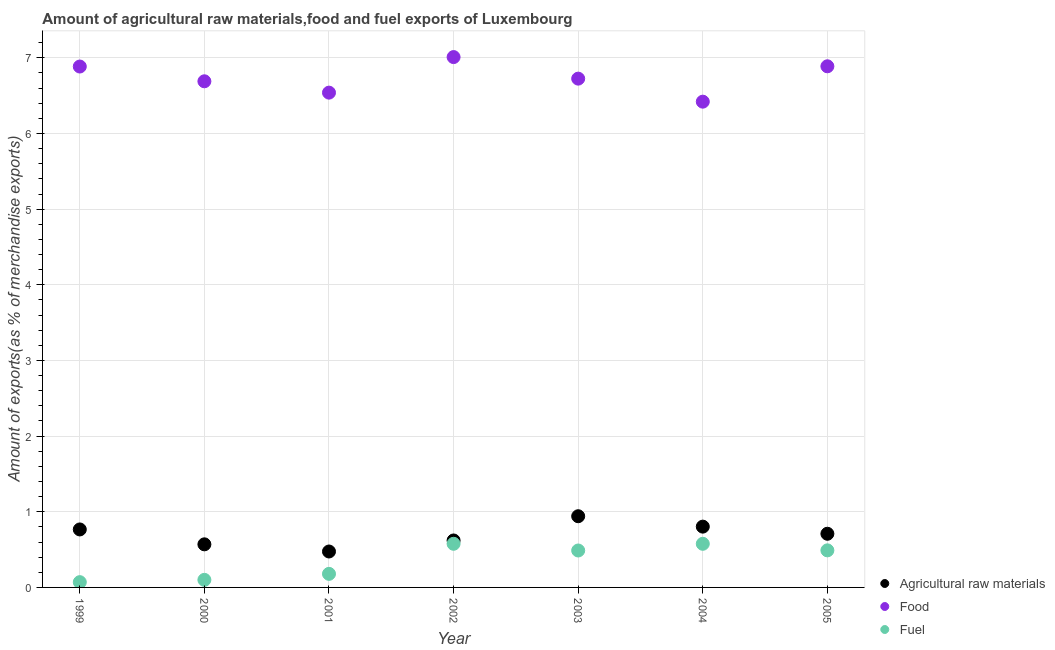What is the percentage of raw materials exports in 1999?
Keep it short and to the point. 0.77. Across all years, what is the maximum percentage of food exports?
Give a very brief answer. 7.01. Across all years, what is the minimum percentage of raw materials exports?
Your response must be concise. 0.47. In which year was the percentage of raw materials exports maximum?
Ensure brevity in your answer.  2003. In which year was the percentage of raw materials exports minimum?
Ensure brevity in your answer.  2001. What is the total percentage of food exports in the graph?
Make the answer very short. 47.16. What is the difference between the percentage of fuel exports in 1999 and that in 2001?
Offer a terse response. -0.11. What is the difference between the percentage of raw materials exports in 2002 and the percentage of food exports in 2004?
Your answer should be very brief. -5.8. What is the average percentage of fuel exports per year?
Keep it short and to the point. 0.35. In the year 2000, what is the difference between the percentage of fuel exports and percentage of raw materials exports?
Give a very brief answer. -0.47. What is the ratio of the percentage of food exports in 2004 to that in 2005?
Your answer should be compact. 0.93. Is the percentage of fuel exports in 2002 less than that in 2005?
Offer a terse response. No. Is the difference between the percentage of food exports in 2001 and 2002 greater than the difference between the percentage of raw materials exports in 2001 and 2002?
Make the answer very short. No. What is the difference between the highest and the second highest percentage of raw materials exports?
Provide a short and direct response. 0.14. What is the difference between the highest and the lowest percentage of fuel exports?
Make the answer very short. 0.51. Is the sum of the percentage of raw materials exports in 2000 and 2002 greater than the maximum percentage of food exports across all years?
Keep it short and to the point. No. Is it the case that in every year, the sum of the percentage of raw materials exports and percentage of food exports is greater than the percentage of fuel exports?
Your answer should be very brief. Yes. How many dotlines are there?
Give a very brief answer. 3. Where does the legend appear in the graph?
Offer a very short reply. Bottom right. What is the title of the graph?
Make the answer very short. Amount of agricultural raw materials,food and fuel exports of Luxembourg. Does "Capital account" appear as one of the legend labels in the graph?
Provide a short and direct response. No. What is the label or title of the Y-axis?
Offer a very short reply. Amount of exports(as % of merchandise exports). What is the Amount of exports(as % of merchandise exports) in Agricultural raw materials in 1999?
Offer a very short reply. 0.77. What is the Amount of exports(as % of merchandise exports) of Food in 1999?
Make the answer very short. 6.88. What is the Amount of exports(as % of merchandise exports) of Fuel in 1999?
Your answer should be very brief. 0.07. What is the Amount of exports(as % of merchandise exports) of Agricultural raw materials in 2000?
Your answer should be compact. 0.57. What is the Amount of exports(as % of merchandise exports) of Food in 2000?
Your answer should be very brief. 6.69. What is the Amount of exports(as % of merchandise exports) in Fuel in 2000?
Your answer should be very brief. 0.1. What is the Amount of exports(as % of merchandise exports) in Agricultural raw materials in 2001?
Keep it short and to the point. 0.47. What is the Amount of exports(as % of merchandise exports) of Food in 2001?
Keep it short and to the point. 6.54. What is the Amount of exports(as % of merchandise exports) in Fuel in 2001?
Offer a terse response. 0.18. What is the Amount of exports(as % of merchandise exports) of Agricultural raw materials in 2002?
Make the answer very short. 0.62. What is the Amount of exports(as % of merchandise exports) in Food in 2002?
Offer a terse response. 7.01. What is the Amount of exports(as % of merchandise exports) of Fuel in 2002?
Make the answer very short. 0.58. What is the Amount of exports(as % of merchandise exports) of Agricultural raw materials in 2003?
Offer a very short reply. 0.94. What is the Amount of exports(as % of merchandise exports) in Food in 2003?
Provide a short and direct response. 6.72. What is the Amount of exports(as % of merchandise exports) of Fuel in 2003?
Provide a short and direct response. 0.49. What is the Amount of exports(as % of merchandise exports) of Agricultural raw materials in 2004?
Your response must be concise. 0.8. What is the Amount of exports(as % of merchandise exports) of Food in 2004?
Provide a short and direct response. 6.42. What is the Amount of exports(as % of merchandise exports) in Fuel in 2004?
Make the answer very short. 0.58. What is the Amount of exports(as % of merchandise exports) in Agricultural raw materials in 2005?
Provide a succinct answer. 0.71. What is the Amount of exports(as % of merchandise exports) of Food in 2005?
Give a very brief answer. 6.89. What is the Amount of exports(as % of merchandise exports) in Fuel in 2005?
Offer a very short reply. 0.49. Across all years, what is the maximum Amount of exports(as % of merchandise exports) in Agricultural raw materials?
Give a very brief answer. 0.94. Across all years, what is the maximum Amount of exports(as % of merchandise exports) in Food?
Provide a succinct answer. 7.01. Across all years, what is the maximum Amount of exports(as % of merchandise exports) of Fuel?
Offer a very short reply. 0.58. Across all years, what is the minimum Amount of exports(as % of merchandise exports) in Agricultural raw materials?
Your answer should be very brief. 0.47. Across all years, what is the minimum Amount of exports(as % of merchandise exports) in Food?
Provide a short and direct response. 6.42. Across all years, what is the minimum Amount of exports(as % of merchandise exports) in Fuel?
Offer a terse response. 0.07. What is the total Amount of exports(as % of merchandise exports) of Agricultural raw materials in the graph?
Your answer should be very brief. 4.89. What is the total Amount of exports(as % of merchandise exports) in Food in the graph?
Offer a terse response. 47.16. What is the total Amount of exports(as % of merchandise exports) of Fuel in the graph?
Offer a very short reply. 2.48. What is the difference between the Amount of exports(as % of merchandise exports) of Agricultural raw materials in 1999 and that in 2000?
Provide a short and direct response. 0.2. What is the difference between the Amount of exports(as % of merchandise exports) in Food in 1999 and that in 2000?
Provide a short and direct response. 0.2. What is the difference between the Amount of exports(as % of merchandise exports) in Fuel in 1999 and that in 2000?
Provide a succinct answer. -0.03. What is the difference between the Amount of exports(as % of merchandise exports) in Agricultural raw materials in 1999 and that in 2001?
Offer a very short reply. 0.29. What is the difference between the Amount of exports(as % of merchandise exports) of Food in 1999 and that in 2001?
Your response must be concise. 0.35. What is the difference between the Amount of exports(as % of merchandise exports) in Fuel in 1999 and that in 2001?
Offer a terse response. -0.11. What is the difference between the Amount of exports(as % of merchandise exports) in Agricultural raw materials in 1999 and that in 2002?
Ensure brevity in your answer.  0.15. What is the difference between the Amount of exports(as % of merchandise exports) of Food in 1999 and that in 2002?
Offer a terse response. -0.12. What is the difference between the Amount of exports(as % of merchandise exports) of Fuel in 1999 and that in 2002?
Provide a succinct answer. -0.51. What is the difference between the Amount of exports(as % of merchandise exports) in Agricultural raw materials in 1999 and that in 2003?
Your answer should be very brief. -0.17. What is the difference between the Amount of exports(as % of merchandise exports) in Food in 1999 and that in 2003?
Provide a succinct answer. 0.16. What is the difference between the Amount of exports(as % of merchandise exports) of Fuel in 1999 and that in 2003?
Your answer should be very brief. -0.42. What is the difference between the Amount of exports(as % of merchandise exports) of Agricultural raw materials in 1999 and that in 2004?
Ensure brevity in your answer.  -0.04. What is the difference between the Amount of exports(as % of merchandise exports) of Food in 1999 and that in 2004?
Offer a very short reply. 0.46. What is the difference between the Amount of exports(as % of merchandise exports) in Fuel in 1999 and that in 2004?
Give a very brief answer. -0.51. What is the difference between the Amount of exports(as % of merchandise exports) in Agricultural raw materials in 1999 and that in 2005?
Provide a succinct answer. 0.06. What is the difference between the Amount of exports(as % of merchandise exports) in Food in 1999 and that in 2005?
Make the answer very short. -0. What is the difference between the Amount of exports(as % of merchandise exports) of Fuel in 1999 and that in 2005?
Keep it short and to the point. -0.42. What is the difference between the Amount of exports(as % of merchandise exports) in Agricultural raw materials in 2000 and that in 2001?
Your answer should be compact. 0.09. What is the difference between the Amount of exports(as % of merchandise exports) of Fuel in 2000 and that in 2001?
Offer a terse response. -0.08. What is the difference between the Amount of exports(as % of merchandise exports) in Agricultural raw materials in 2000 and that in 2002?
Make the answer very short. -0.05. What is the difference between the Amount of exports(as % of merchandise exports) of Food in 2000 and that in 2002?
Keep it short and to the point. -0.32. What is the difference between the Amount of exports(as % of merchandise exports) in Fuel in 2000 and that in 2002?
Keep it short and to the point. -0.48. What is the difference between the Amount of exports(as % of merchandise exports) of Agricultural raw materials in 2000 and that in 2003?
Provide a succinct answer. -0.37. What is the difference between the Amount of exports(as % of merchandise exports) of Food in 2000 and that in 2003?
Your answer should be compact. -0.04. What is the difference between the Amount of exports(as % of merchandise exports) of Fuel in 2000 and that in 2003?
Make the answer very short. -0.39. What is the difference between the Amount of exports(as % of merchandise exports) in Agricultural raw materials in 2000 and that in 2004?
Give a very brief answer. -0.23. What is the difference between the Amount of exports(as % of merchandise exports) of Food in 2000 and that in 2004?
Your answer should be compact. 0.27. What is the difference between the Amount of exports(as % of merchandise exports) of Fuel in 2000 and that in 2004?
Provide a succinct answer. -0.48. What is the difference between the Amount of exports(as % of merchandise exports) of Agricultural raw materials in 2000 and that in 2005?
Ensure brevity in your answer.  -0.14. What is the difference between the Amount of exports(as % of merchandise exports) in Food in 2000 and that in 2005?
Keep it short and to the point. -0.2. What is the difference between the Amount of exports(as % of merchandise exports) of Fuel in 2000 and that in 2005?
Provide a succinct answer. -0.39. What is the difference between the Amount of exports(as % of merchandise exports) in Agricultural raw materials in 2001 and that in 2002?
Your response must be concise. -0.15. What is the difference between the Amount of exports(as % of merchandise exports) of Food in 2001 and that in 2002?
Offer a terse response. -0.47. What is the difference between the Amount of exports(as % of merchandise exports) of Fuel in 2001 and that in 2002?
Your answer should be compact. -0.4. What is the difference between the Amount of exports(as % of merchandise exports) of Agricultural raw materials in 2001 and that in 2003?
Offer a terse response. -0.47. What is the difference between the Amount of exports(as % of merchandise exports) in Food in 2001 and that in 2003?
Make the answer very short. -0.19. What is the difference between the Amount of exports(as % of merchandise exports) in Fuel in 2001 and that in 2003?
Ensure brevity in your answer.  -0.31. What is the difference between the Amount of exports(as % of merchandise exports) in Agricultural raw materials in 2001 and that in 2004?
Offer a terse response. -0.33. What is the difference between the Amount of exports(as % of merchandise exports) in Food in 2001 and that in 2004?
Offer a very short reply. 0.12. What is the difference between the Amount of exports(as % of merchandise exports) of Fuel in 2001 and that in 2004?
Keep it short and to the point. -0.4. What is the difference between the Amount of exports(as % of merchandise exports) in Agricultural raw materials in 2001 and that in 2005?
Ensure brevity in your answer.  -0.23. What is the difference between the Amount of exports(as % of merchandise exports) of Food in 2001 and that in 2005?
Make the answer very short. -0.35. What is the difference between the Amount of exports(as % of merchandise exports) in Fuel in 2001 and that in 2005?
Offer a terse response. -0.31. What is the difference between the Amount of exports(as % of merchandise exports) in Agricultural raw materials in 2002 and that in 2003?
Make the answer very short. -0.32. What is the difference between the Amount of exports(as % of merchandise exports) in Food in 2002 and that in 2003?
Provide a succinct answer. 0.28. What is the difference between the Amount of exports(as % of merchandise exports) of Fuel in 2002 and that in 2003?
Offer a very short reply. 0.09. What is the difference between the Amount of exports(as % of merchandise exports) in Agricultural raw materials in 2002 and that in 2004?
Make the answer very short. -0.18. What is the difference between the Amount of exports(as % of merchandise exports) of Food in 2002 and that in 2004?
Offer a terse response. 0.59. What is the difference between the Amount of exports(as % of merchandise exports) of Fuel in 2002 and that in 2004?
Ensure brevity in your answer.  0. What is the difference between the Amount of exports(as % of merchandise exports) in Agricultural raw materials in 2002 and that in 2005?
Offer a terse response. -0.09. What is the difference between the Amount of exports(as % of merchandise exports) in Food in 2002 and that in 2005?
Your answer should be very brief. 0.12. What is the difference between the Amount of exports(as % of merchandise exports) in Fuel in 2002 and that in 2005?
Provide a short and direct response. 0.09. What is the difference between the Amount of exports(as % of merchandise exports) of Agricultural raw materials in 2003 and that in 2004?
Your response must be concise. 0.14. What is the difference between the Amount of exports(as % of merchandise exports) of Food in 2003 and that in 2004?
Your answer should be compact. 0.3. What is the difference between the Amount of exports(as % of merchandise exports) of Fuel in 2003 and that in 2004?
Provide a succinct answer. -0.09. What is the difference between the Amount of exports(as % of merchandise exports) in Agricultural raw materials in 2003 and that in 2005?
Make the answer very short. 0.23. What is the difference between the Amount of exports(as % of merchandise exports) in Food in 2003 and that in 2005?
Your response must be concise. -0.16. What is the difference between the Amount of exports(as % of merchandise exports) of Fuel in 2003 and that in 2005?
Give a very brief answer. -0. What is the difference between the Amount of exports(as % of merchandise exports) of Agricultural raw materials in 2004 and that in 2005?
Give a very brief answer. 0.09. What is the difference between the Amount of exports(as % of merchandise exports) in Food in 2004 and that in 2005?
Provide a succinct answer. -0.47. What is the difference between the Amount of exports(as % of merchandise exports) of Fuel in 2004 and that in 2005?
Provide a short and direct response. 0.09. What is the difference between the Amount of exports(as % of merchandise exports) in Agricultural raw materials in 1999 and the Amount of exports(as % of merchandise exports) in Food in 2000?
Ensure brevity in your answer.  -5.92. What is the difference between the Amount of exports(as % of merchandise exports) in Agricultural raw materials in 1999 and the Amount of exports(as % of merchandise exports) in Fuel in 2000?
Offer a very short reply. 0.67. What is the difference between the Amount of exports(as % of merchandise exports) of Food in 1999 and the Amount of exports(as % of merchandise exports) of Fuel in 2000?
Your answer should be compact. 6.79. What is the difference between the Amount of exports(as % of merchandise exports) in Agricultural raw materials in 1999 and the Amount of exports(as % of merchandise exports) in Food in 2001?
Your response must be concise. -5.77. What is the difference between the Amount of exports(as % of merchandise exports) in Agricultural raw materials in 1999 and the Amount of exports(as % of merchandise exports) in Fuel in 2001?
Give a very brief answer. 0.59. What is the difference between the Amount of exports(as % of merchandise exports) of Food in 1999 and the Amount of exports(as % of merchandise exports) of Fuel in 2001?
Provide a succinct answer. 6.71. What is the difference between the Amount of exports(as % of merchandise exports) in Agricultural raw materials in 1999 and the Amount of exports(as % of merchandise exports) in Food in 2002?
Offer a terse response. -6.24. What is the difference between the Amount of exports(as % of merchandise exports) in Agricultural raw materials in 1999 and the Amount of exports(as % of merchandise exports) in Fuel in 2002?
Keep it short and to the point. 0.19. What is the difference between the Amount of exports(as % of merchandise exports) of Food in 1999 and the Amount of exports(as % of merchandise exports) of Fuel in 2002?
Provide a succinct answer. 6.31. What is the difference between the Amount of exports(as % of merchandise exports) in Agricultural raw materials in 1999 and the Amount of exports(as % of merchandise exports) in Food in 2003?
Offer a terse response. -5.96. What is the difference between the Amount of exports(as % of merchandise exports) of Agricultural raw materials in 1999 and the Amount of exports(as % of merchandise exports) of Fuel in 2003?
Keep it short and to the point. 0.28. What is the difference between the Amount of exports(as % of merchandise exports) of Food in 1999 and the Amount of exports(as % of merchandise exports) of Fuel in 2003?
Make the answer very short. 6.4. What is the difference between the Amount of exports(as % of merchandise exports) of Agricultural raw materials in 1999 and the Amount of exports(as % of merchandise exports) of Food in 2004?
Offer a terse response. -5.65. What is the difference between the Amount of exports(as % of merchandise exports) in Agricultural raw materials in 1999 and the Amount of exports(as % of merchandise exports) in Fuel in 2004?
Your response must be concise. 0.19. What is the difference between the Amount of exports(as % of merchandise exports) in Food in 1999 and the Amount of exports(as % of merchandise exports) in Fuel in 2004?
Your response must be concise. 6.31. What is the difference between the Amount of exports(as % of merchandise exports) in Agricultural raw materials in 1999 and the Amount of exports(as % of merchandise exports) in Food in 2005?
Offer a terse response. -6.12. What is the difference between the Amount of exports(as % of merchandise exports) in Agricultural raw materials in 1999 and the Amount of exports(as % of merchandise exports) in Fuel in 2005?
Offer a terse response. 0.28. What is the difference between the Amount of exports(as % of merchandise exports) in Food in 1999 and the Amount of exports(as % of merchandise exports) in Fuel in 2005?
Offer a very short reply. 6.39. What is the difference between the Amount of exports(as % of merchandise exports) of Agricultural raw materials in 2000 and the Amount of exports(as % of merchandise exports) of Food in 2001?
Give a very brief answer. -5.97. What is the difference between the Amount of exports(as % of merchandise exports) of Agricultural raw materials in 2000 and the Amount of exports(as % of merchandise exports) of Fuel in 2001?
Provide a succinct answer. 0.39. What is the difference between the Amount of exports(as % of merchandise exports) of Food in 2000 and the Amount of exports(as % of merchandise exports) of Fuel in 2001?
Offer a terse response. 6.51. What is the difference between the Amount of exports(as % of merchandise exports) of Agricultural raw materials in 2000 and the Amount of exports(as % of merchandise exports) of Food in 2002?
Keep it short and to the point. -6.44. What is the difference between the Amount of exports(as % of merchandise exports) of Agricultural raw materials in 2000 and the Amount of exports(as % of merchandise exports) of Fuel in 2002?
Provide a short and direct response. -0.01. What is the difference between the Amount of exports(as % of merchandise exports) in Food in 2000 and the Amount of exports(as % of merchandise exports) in Fuel in 2002?
Offer a very short reply. 6.11. What is the difference between the Amount of exports(as % of merchandise exports) of Agricultural raw materials in 2000 and the Amount of exports(as % of merchandise exports) of Food in 2003?
Make the answer very short. -6.16. What is the difference between the Amount of exports(as % of merchandise exports) in Agricultural raw materials in 2000 and the Amount of exports(as % of merchandise exports) in Fuel in 2003?
Make the answer very short. 0.08. What is the difference between the Amount of exports(as % of merchandise exports) in Food in 2000 and the Amount of exports(as % of merchandise exports) in Fuel in 2003?
Provide a succinct answer. 6.2. What is the difference between the Amount of exports(as % of merchandise exports) in Agricultural raw materials in 2000 and the Amount of exports(as % of merchandise exports) in Food in 2004?
Your answer should be very brief. -5.85. What is the difference between the Amount of exports(as % of merchandise exports) of Agricultural raw materials in 2000 and the Amount of exports(as % of merchandise exports) of Fuel in 2004?
Make the answer very short. -0.01. What is the difference between the Amount of exports(as % of merchandise exports) in Food in 2000 and the Amount of exports(as % of merchandise exports) in Fuel in 2004?
Offer a very short reply. 6.11. What is the difference between the Amount of exports(as % of merchandise exports) in Agricultural raw materials in 2000 and the Amount of exports(as % of merchandise exports) in Food in 2005?
Your answer should be compact. -6.32. What is the difference between the Amount of exports(as % of merchandise exports) in Agricultural raw materials in 2000 and the Amount of exports(as % of merchandise exports) in Fuel in 2005?
Give a very brief answer. 0.08. What is the difference between the Amount of exports(as % of merchandise exports) in Food in 2000 and the Amount of exports(as % of merchandise exports) in Fuel in 2005?
Make the answer very short. 6.2. What is the difference between the Amount of exports(as % of merchandise exports) of Agricultural raw materials in 2001 and the Amount of exports(as % of merchandise exports) of Food in 2002?
Offer a terse response. -6.54. What is the difference between the Amount of exports(as % of merchandise exports) of Agricultural raw materials in 2001 and the Amount of exports(as % of merchandise exports) of Fuel in 2002?
Make the answer very short. -0.1. What is the difference between the Amount of exports(as % of merchandise exports) of Food in 2001 and the Amount of exports(as % of merchandise exports) of Fuel in 2002?
Provide a succinct answer. 5.96. What is the difference between the Amount of exports(as % of merchandise exports) in Agricultural raw materials in 2001 and the Amount of exports(as % of merchandise exports) in Food in 2003?
Ensure brevity in your answer.  -6.25. What is the difference between the Amount of exports(as % of merchandise exports) in Agricultural raw materials in 2001 and the Amount of exports(as % of merchandise exports) in Fuel in 2003?
Give a very brief answer. -0.01. What is the difference between the Amount of exports(as % of merchandise exports) of Food in 2001 and the Amount of exports(as % of merchandise exports) of Fuel in 2003?
Offer a very short reply. 6.05. What is the difference between the Amount of exports(as % of merchandise exports) of Agricultural raw materials in 2001 and the Amount of exports(as % of merchandise exports) of Food in 2004?
Give a very brief answer. -5.95. What is the difference between the Amount of exports(as % of merchandise exports) of Agricultural raw materials in 2001 and the Amount of exports(as % of merchandise exports) of Fuel in 2004?
Give a very brief answer. -0.1. What is the difference between the Amount of exports(as % of merchandise exports) in Food in 2001 and the Amount of exports(as % of merchandise exports) in Fuel in 2004?
Your response must be concise. 5.96. What is the difference between the Amount of exports(as % of merchandise exports) of Agricultural raw materials in 2001 and the Amount of exports(as % of merchandise exports) of Food in 2005?
Ensure brevity in your answer.  -6.41. What is the difference between the Amount of exports(as % of merchandise exports) in Agricultural raw materials in 2001 and the Amount of exports(as % of merchandise exports) in Fuel in 2005?
Offer a very short reply. -0.02. What is the difference between the Amount of exports(as % of merchandise exports) in Food in 2001 and the Amount of exports(as % of merchandise exports) in Fuel in 2005?
Provide a short and direct response. 6.05. What is the difference between the Amount of exports(as % of merchandise exports) in Agricultural raw materials in 2002 and the Amount of exports(as % of merchandise exports) in Food in 2003?
Your answer should be very brief. -6.1. What is the difference between the Amount of exports(as % of merchandise exports) in Agricultural raw materials in 2002 and the Amount of exports(as % of merchandise exports) in Fuel in 2003?
Offer a very short reply. 0.13. What is the difference between the Amount of exports(as % of merchandise exports) in Food in 2002 and the Amount of exports(as % of merchandise exports) in Fuel in 2003?
Your response must be concise. 6.52. What is the difference between the Amount of exports(as % of merchandise exports) of Agricultural raw materials in 2002 and the Amount of exports(as % of merchandise exports) of Food in 2004?
Make the answer very short. -5.8. What is the difference between the Amount of exports(as % of merchandise exports) of Agricultural raw materials in 2002 and the Amount of exports(as % of merchandise exports) of Fuel in 2004?
Keep it short and to the point. 0.04. What is the difference between the Amount of exports(as % of merchandise exports) in Food in 2002 and the Amount of exports(as % of merchandise exports) in Fuel in 2004?
Give a very brief answer. 6.43. What is the difference between the Amount of exports(as % of merchandise exports) of Agricultural raw materials in 2002 and the Amount of exports(as % of merchandise exports) of Food in 2005?
Offer a terse response. -6.27. What is the difference between the Amount of exports(as % of merchandise exports) in Agricultural raw materials in 2002 and the Amount of exports(as % of merchandise exports) in Fuel in 2005?
Your response must be concise. 0.13. What is the difference between the Amount of exports(as % of merchandise exports) in Food in 2002 and the Amount of exports(as % of merchandise exports) in Fuel in 2005?
Give a very brief answer. 6.52. What is the difference between the Amount of exports(as % of merchandise exports) in Agricultural raw materials in 2003 and the Amount of exports(as % of merchandise exports) in Food in 2004?
Your response must be concise. -5.48. What is the difference between the Amount of exports(as % of merchandise exports) in Agricultural raw materials in 2003 and the Amount of exports(as % of merchandise exports) in Fuel in 2004?
Offer a very short reply. 0.36. What is the difference between the Amount of exports(as % of merchandise exports) in Food in 2003 and the Amount of exports(as % of merchandise exports) in Fuel in 2004?
Your response must be concise. 6.15. What is the difference between the Amount of exports(as % of merchandise exports) in Agricultural raw materials in 2003 and the Amount of exports(as % of merchandise exports) in Food in 2005?
Provide a short and direct response. -5.95. What is the difference between the Amount of exports(as % of merchandise exports) of Agricultural raw materials in 2003 and the Amount of exports(as % of merchandise exports) of Fuel in 2005?
Your answer should be very brief. 0.45. What is the difference between the Amount of exports(as % of merchandise exports) in Food in 2003 and the Amount of exports(as % of merchandise exports) in Fuel in 2005?
Make the answer very short. 6.24. What is the difference between the Amount of exports(as % of merchandise exports) in Agricultural raw materials in 2004 and the Amount of exports(as % of merchandise exports) in Food in 2005?
Make the answer very short. -6.08. What is the difference between the Amount of exports(as % of merchandise exports) of Agricultural raw materials in 2004 and the Amount of exports(as % of merchandise exports) of Fuel in 2005?
Your answer should be compact. 0.31. What is the difference between the Amount of exports(as % of merchandise exports) of Food in 2004 and the Amount of exports(as % of merchandise exports) of Fuel in 2005?
Ensure brevity in your answer.  5.93. What is the average Amount of exports(as % of merchandise exports) in Agricultural raw materials per year?
Give a very brief answer. 0.7. What is the average Amount of exports(as % of merchandise exports) in Food per year?
Your answer should be very brief. 6.74. What is the average Amount of exports(as % of merchandise exports) of Fuel per year?
Your answer should be very brief. 0.35. In the year 1999, what is the difference between the Amount of exports(as % of merchandise exports) in Agricultural raw materials and Amount of exports(as % of merchandise exports) in Food?
Offer a terse response. -6.12. In the year 1999, what is the difference between the Amount of exports(as % of merchandise exports) of Agricultural raw materials and Amount of exports(as % of merchandise exports) of Fuel?
Your response must be concise. 0.7. In the year 1999, what is the difference between the Amount of exports(as % of merchandise exports) in Food and Amount of exports(as % of merchandise exports) in Fuel?
Make the answer very short. 6.82. In the year 2000, what is the difference between the Amount of exports(as % of merchandise exports) of Agricultural raw materials and Amount of exports(as % of merchandise exports) of Food?
Your answer should be compact. -6.12. In the year 2000, what is the difference between the Amount of exports(as % of merchandise exports) in Agricultural raw materials and Amount of exports(as % of merchandise exports) in Fuel?
Ensure brevity in your answer.  0.47. In the year 2000, what is the difference between the Amount of exports(as % of merchandise exports) of Food and Amount of exports(as % of merchandise exports) of Fuel?
Give a very brief answer. 6.59. In the year 2001, what is the difference between the Amount of exports(as % of merchandise exports) in Agricultural raw materials and Amount of exports(as % of merchandise exports) in Food?
Offer a terse response. -6.07. In the year 2001, what is the difference between the Amount of exports(as % of merchandise exports) of Agricultural raw materials and Amount of exports(as % of merchandise exports) of Fuel?
Ensure brevity in your answer.  0.3. In the year 2001, what is the difference between the Amount of exports(as % of merchandise exports) in Food and Amount of exports(as % of merchandise exports) in Fuel?
Your answer should be compact. 6.36. In the year 2002, what is the difference between the Amount of exports(as % of merchandise exports) in Agricultural raw materials and Amount of exports(as % of merchandise exports) in Food?
Your answer should be compact. -6.39. In the year 2002, what is the difference between the Amount of exports(as % of merchandise exports) of Agricultural raw materials and Amount of exports(as % of merchandise exports) of Fuel?
Offer a very short reply. 0.04. In the year 2002, what is the difference between the Amount of exports(as % of merchandise exports) in Food and Amount of exports(as % of merchandise exports) in Fuel?
Offer a very short reply. 6.43. In the year 2003, what is the difference between the Amount of exports(as % of merchandise exports) in Agricultural raw materials and Amount of exports(as % of merchandise exports) in Food?
Give a very brief answer. -5.78. In the year 2003, what is the difference between the Amount of exports(as % of merchandise exports) of Agricultural raw materials and Amount of exports(as % of merchandise exports) of Fuel?
Your answer should be compact. 0.45. In the year 2003, what is the difference between the Amount of exports(as % of merchandise exports) in Food and Amount of exports(as % of merchandise exports) in Fuel?
Ensure brevity in your answer.  6.24. In the year 2004, what is the difference between the Amount of exports(as % of merchandise exports) of Agricultural raw materials and Amount of exports(as % of merchandise exports) of Food?
Make the answer very short. -5.62. In the year 2004, what is the difference between the Amount of exports(as % of merchandise exports) in Agricultural raw materials and Amount of exports(as % of merchandise exports) in Fuel?
Your response must be concise. 0.23. In the year 2004, what is the difference between the Amount of exports(as % of merchandise exports) in Food and Amount of exports(as % of merchandise exports) in Fuel?
Make the answer very short. 5.84. In the year 2005, what is the difference between the Amount of exports(as % of merchandise exports) of Agricultural raw materials and Amount of exports(as % of merchandise exports) of Food?
Your response must be concise. -6.18. In the year 2005, what is the difference between the Amount of exports(as % of merchandise exports) of Agricultural raw materials and Amount of exports(as % of merchandise exports) of Fuel?
Provide a succinct answer. 0.22. In the year 2005, what is the difference between the Amount of exports(as % of merchandise exports) in Food and Amount of exports(as % of merchandise exports) in Fuel?
Ensure brevity in your answer.  6.4. What is the ratio of the Amount of exports(as % of merchandise exports) in Agricultural raw materials in 1999 to that in 2000?
Keep it short and to the point. 1.35. What is the ratio of the Amount of exports(as % of merchandise exports) of Food in 1999 to that in 2000?
Make the answer very short. 1.03. What is the ratio of the Amount of exports(as % of merchandise exports) in Fuel in 1999 to that in 2000?
Provide a short and direct response. 0.7. What is the ratio of the Amount of exports(as % of merchandise exports) of Agricultural raw materials in 1999 to that in 2001?
Your response must be concise. 1.61. What is the ratio of the Amount of exports(as % of merchandise exports) in Food in 1999 to that in 2001?
Your response must be concise. 1.05. What is the ratio of the Amount of exports(as % of merchandise exports) of Fuel in 1999 to that in 2001?
Make the answer very short. 0.39. What is the ratio of the Amount of exports(as % of merchandise exports) of Agricultural raw materials in 1999 to that in 2002?
Ensure brevity in your answer.  1.23. What is the ratio of the Amount of exports(as % of merchandise exports) in Food in 1999 to that in 2002?
Provide a short and direct response. 0.98. What is the ratio of the Amount of exports(as % of merchandise exports) in Fuel in 1999 to that in 2002?
Keep it short and to the point. 0.12. What is the ratio of the Amount of exports(as % of merchandise exports) in Agricultural raw materials in 1999 to that in 2003?
Provide a succinct answer. 0.81. What is the ratio of the Amount of exports(as % of merchandise exports) of Food in 1999 to that in 2003?
Your answer should be compact. 1.02. What is the ratio of the Amount of exports(as % of merchandise exports) of Fuel in 1999 to that in 2003?
Make the answer very short. 0.14. What is the ratio of the Amount of exports(as % of merchandise exports) of Agricultural raw materials in 1999 to that in 2004?
Provide a succinct answer. 0.95. What is the ratio of the Amount of exports(as % of merchandise exports) of Food in 1999 to that in 2004?
Give a very brief answer. 1.07. What is the ratio of the Amount of exports(as % of merchandise exports) in Fuel in 1999 to that in 2004?
Make the answer very short. 0.12. What is the ratio of the Amount of exports(as % of merchandise exports) of Agricultural raw materials in 1999 to that in 2005?
Keep it short and to the point. 1.08. What is the ratio of the Amount of exports(as % of merchandise exports) of Food in 1999 to that in 2005?
Your response must be concise. 1. What is the ratio of the Amount of exports(as % of merchandise exports) in Fuel in 1999 to that in 2005?
Offer a terse response. 0.14. What is the ratio of the Amount of exports(as % of merchandise exports) in Agricultural raw materials in 2000 to that in 2001?
Ensure brevity in your answer.  1.2. What is the ratio of the Amount of exports(as % of merchandise exports) in Food in 2000 to that in 2001?
Give a very brief answer. 1.02. What is the ratio of the Amount of exports(as % of merchandise exports) in Fuel in 2000 to that in 2001?
Your response must be concise. 0.56. What is the ratio of the Amount of exports(as % of merchandise exports) in Agricultural raw materials in 2000 to that in 2002?
Provide a short and direct response. 0.92. What is the ratio of the Amount of exports(as % of merchandise exports) of Food in 2000 to that in 2002?
Keep it short and to the point. 0.95. What is the ratio of the Amount of exports(as % of merchandise exports) of Fuel in 2000 to that in 2002?
Offer a terse response. 0.17. What is the ratio of the Amount of exports(as % of merchandise exports) of Agricultural raw materials in 2000 to that in 2003?
Your answer should be compact. 0.61. What is the ratio of the Amount of exports(as % of merchandise exports) in Fuel in 2000 to that in 2003?
Provide a succinct answer. 0.2. What is the ratio of the Amount of exports(as % of merchandise exports) in Agricultural raw materials in 2000 to that in 2004?
Provide a short and direct response. 0.71. What is the ratio of the Amount of exports(as % of merchandise exports) in Food in 2000 to that in 2004?
Your answer should be very brief. 1.04. What is the ratio of the Amount of exports(as % of merchandise exports) of Fuel in 2000 to that in 2004?
Your answer should be compact. 0.17. What is the ratio of the Amount of exports(as % of merchandise exports) of Agricultural raw materials in 2000 to that in 2005?
Make the answer very short. 0.8. What is the ratio of the Amount of exports(as % of merchandise exports) of Food in 2000 to that in 2005?
Ensure brevity in your answer.  0.97. What is the ratio of the Amount of exports(as % of merchandise exports) of Fuel in 2000 to that in 2005?
Make the answer very short. 0.2. What is the ratio of the Amount of exports(as % of merchandise exports) of Agricultural raw materials in 2001 to that in 2002?
Offer a terse response. 0.77. What is the ratio of the Amount of exports(as % of merchandise exports) of Food in 2001 to that in 2002?
Give a very brief answer. 0.93. What is the ratio of the Amount of exports(as % of merchandise exports) of Fuel in 2001 to that in 2002?
Your response must be concise. 0.31. What is the ratio of the Amount of exports(as % of merchandise exports) of Agricultural raw materials in 2001 to that in 2003?
Provide a short and direct response. 0.5. What is the ratio of the Amount of exports(as % of merchandise exports) in Food in 2001 to that in 2003?
Keep it short and to the point. 0.97. What is the ratio of the Amount of exports(as % of merchandise exports) in Fuel in 2001 to that in 2003?
Keep it short and to the point. 0.37. What is the ratio of the Amount of exports(as % of merchandise exports) in Agricultural raw materials in 2001 to that in 2004?
Provide a short and direct response. 0.59. What is the ratio of the Amount of exports(as % of merchandise exports) in Food in 2001 to that in 2004?
Ensure brevity in your answer.  1.02. What is the ratio of the Amount of exports(as % of merchandise exports) in Fuel in 2001 to that in 2004?
Offer a terse response. 0.31. What is the ratio of the Amount of exports(as % of merchandise exports) of Agricultural raw materials in 2001 to that in 2005?
Offer a very short reply. 0.67. What is the ratio of the Amount of exports(as % of merchandise exports) of Food in 2001 to that in 2005?
Give a very brief answer. 0.95. What is the ratio of the Amount of exports(as % of merchandise exports) of Fuel in 2001 to that in 2005?
Provide a succinct answer. 0.37. What is the ratio of the Amount of exports(as % of merchandise exports) in Agricultural raw materials in 2002 to that in 2003?
Keep it short and to the point. 0.66. What is the ratio of the Amount of exports(as % of merchandise exports) of Food in 2002 to that in 2003?
Offer a very short reply. 1.04. What is the ratio of the Amount of exports(as % of merchandise exports) of Fuel in 2002 to that in 2003?
Provide a succinct answer. 1.18. What is the ratio of the Amount of exports(as % of merchandise exports) of Agricultural raw materials in 2002 to that in 2004?
Your response must be concise. 0.77. What is the ratio of the Amount of exports(as % of merchandise exports) of Food in 2002 to that in 2004?
Your answer should be very brief. 1.09. What is the ratio of the Amount of exports(as % of merchandise exports) in Fuel in 2002 to that in 2004?
Your answer should be compact. 1. What is the ratio of the Amount of exports(as % of merchandise exports) in Food in 2002 to that in 2005?
Your answer should be compact. 1.02. What is the ratio of the Amount of exports(as % of merchandise exports) in Fuel in 2002 to that in 2005?
Ensure brevity in your answer.  1.18. What is the ratio of the Amount of exports(as % of merchandise exports) in Agricultural raw materials in 2003 to that in 2004?
Offer a terse response. 1.17. What is the ratio of the Amount of exports(as % of merchandise exports) of Food in 2003 to that in 2004?
Provide a short and direct response. 1.05. What is the ratio of the Amount of exports(as % of merchandise exports) of Fuel in 2003 to that in 2004?
Ensure brevity in your answer.  0.85. What is the ratio of the Amount of exports(as % of merchandise exports) in Agricultural raw materials in 2003 to that in 2005?
Keep it short and to the point. 1.33. What is the ratio of the Amount of exports(as % of merchandise exports) of Food in 2003 to that in 2005?
Ensure brevity in your answer.  0.98. What is the ratio of the Amount of exports(as % of merchandise exports) of Agricultural raw materials in 2004 to that in 2005?
Your response must be concise. 1.13. What is the ratio of the Amount of exports(as % of merchandise exports) in Food in 2004 to that in 2005?
Provide a short and direct response. 0.93. What is the ratio of the Amount of exports(as % of merchandise exports) in Fuel in 2004 to that in 2005?
Offer a terse response. 1.18. What is the difference between the highest and the second highest Amount of exports(as % of merchandise exports) of Agricultural raw materials?
Provide a short and direct response. 0.14. What is the difference between the highest and the second highest Amount of exports(as % of merchandise exports) in Food?
Your answer should be very brief. 0.12. What is the difference between the highest and the lowest Amount of exports(as % of merchandise exports) of Agricultural raw materials?
Your answer should be very brief. 0.47. What is the difference between the highest and the lowest Amount of exports(as % of merchandise exports) in Food?
Offer a very short reply. 0.59. What is the difference between the highest and the lowest Amount of exports(as % of merchandise exports) of Fuel?
Ensure brevity in your answer.  0.51. 